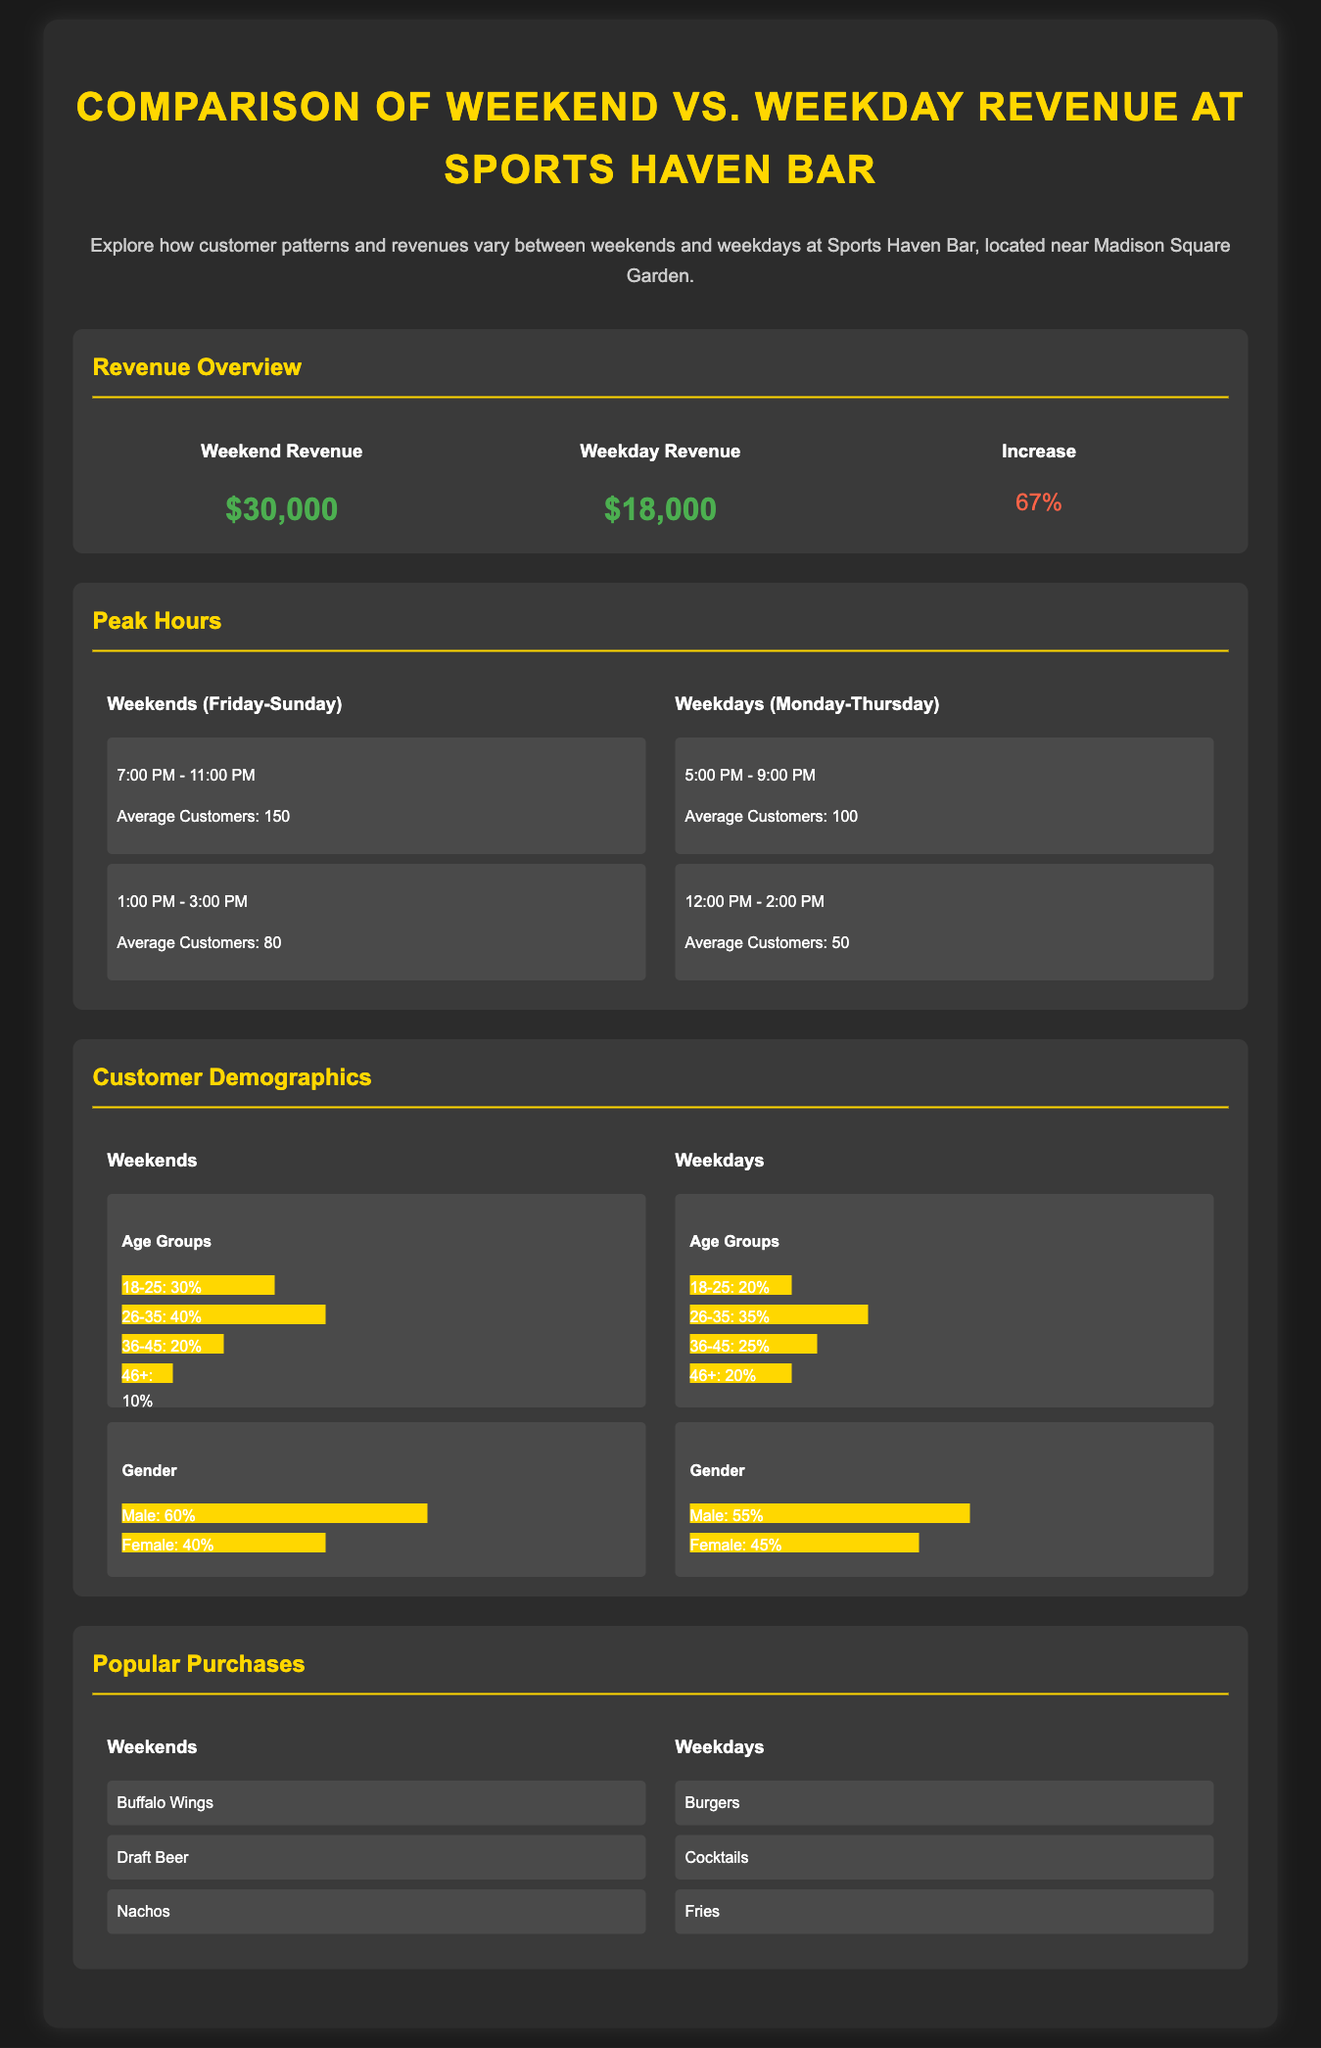What is the weekend revenue? The weekend revenue is stated in the document as $30,000.
Answer: $30,000 What is the weekday revenue? The weekday revenue is specified in the document as $18,000.
Answer: $18,000 What is the percentage increase in revenue from weekday to weekend? The percentage increase is found in the section as 67%.
Answer: 67% What are the peak hours for weekends? The peak hours for weekends are listed as 7:00 PM - 11:00 PM and 1:00 PM - 3:00 PM.
Answer: 7:00 PM - 11:00 PM, 1:00 PM - 3:00 PM What is the average number of customers during peak weekend hours? The average number of customers during peak weekend hours is stated as 150.
Answer: 150 What age group has the highest percentage of customers on weekends? The age group with the highest percentage of customers on weekends is 26-35, which is 40%.
Answer: 26-35: 40% Which purchase is most popular on weekdays? The most popular purchase on weekdays is listed as Burgers.
Answer: Burgers How many average customers are there during weekdays at peak times? The average number of customers during peak weekday hours is stated as 100.
Answer: 100 Which gender has a higher percentage of customers on weekends? The gender with a higher percentage of customers on weekends is Male at 60%.
Answer: Male: 60% 